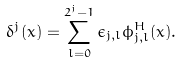Convert formula to latex. <formula><loc_0><loc_0><loc_500><loc_500>\delta ^ { j } ( x ) = \sum _ { l = 0 } ^ { 2 ^ { j } - 1 } \epsilon _ { j , l } \phi _ { j , l } ^ { H } ( x ) .</formula> 